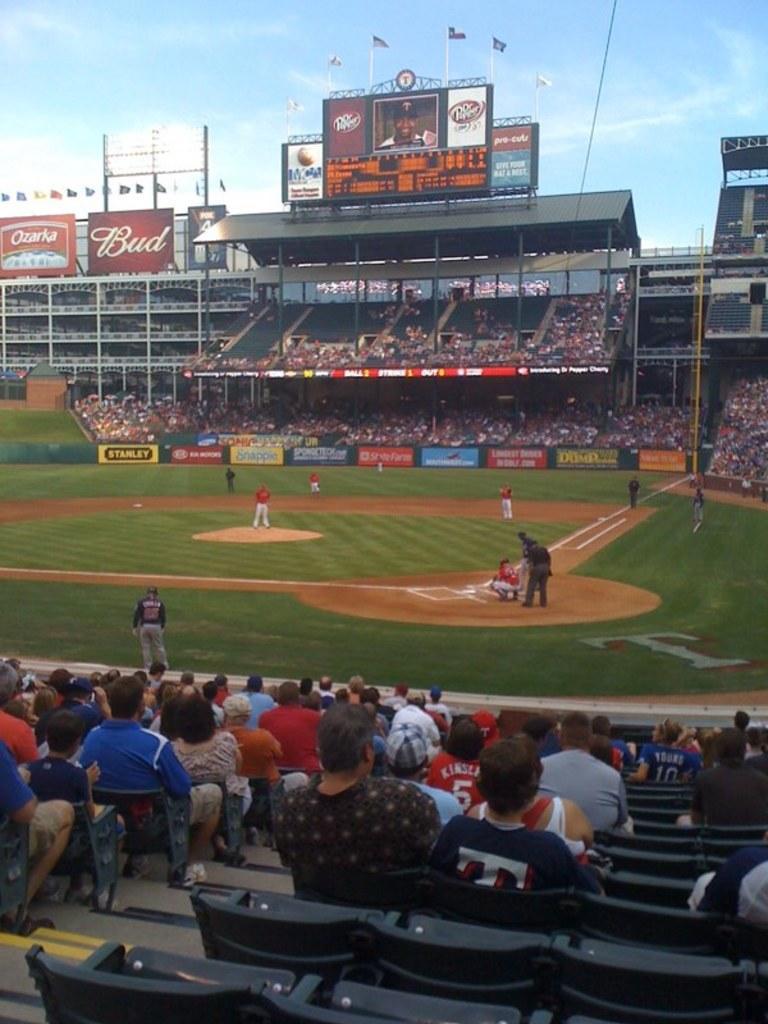How would you summarize this image in a sentence or two? The image is taken in the stadium. In the center of the image we can see people playing a game. At the bottom there are seats and we can see crowd. In the background there is a board and screen. At the top there is sky. 